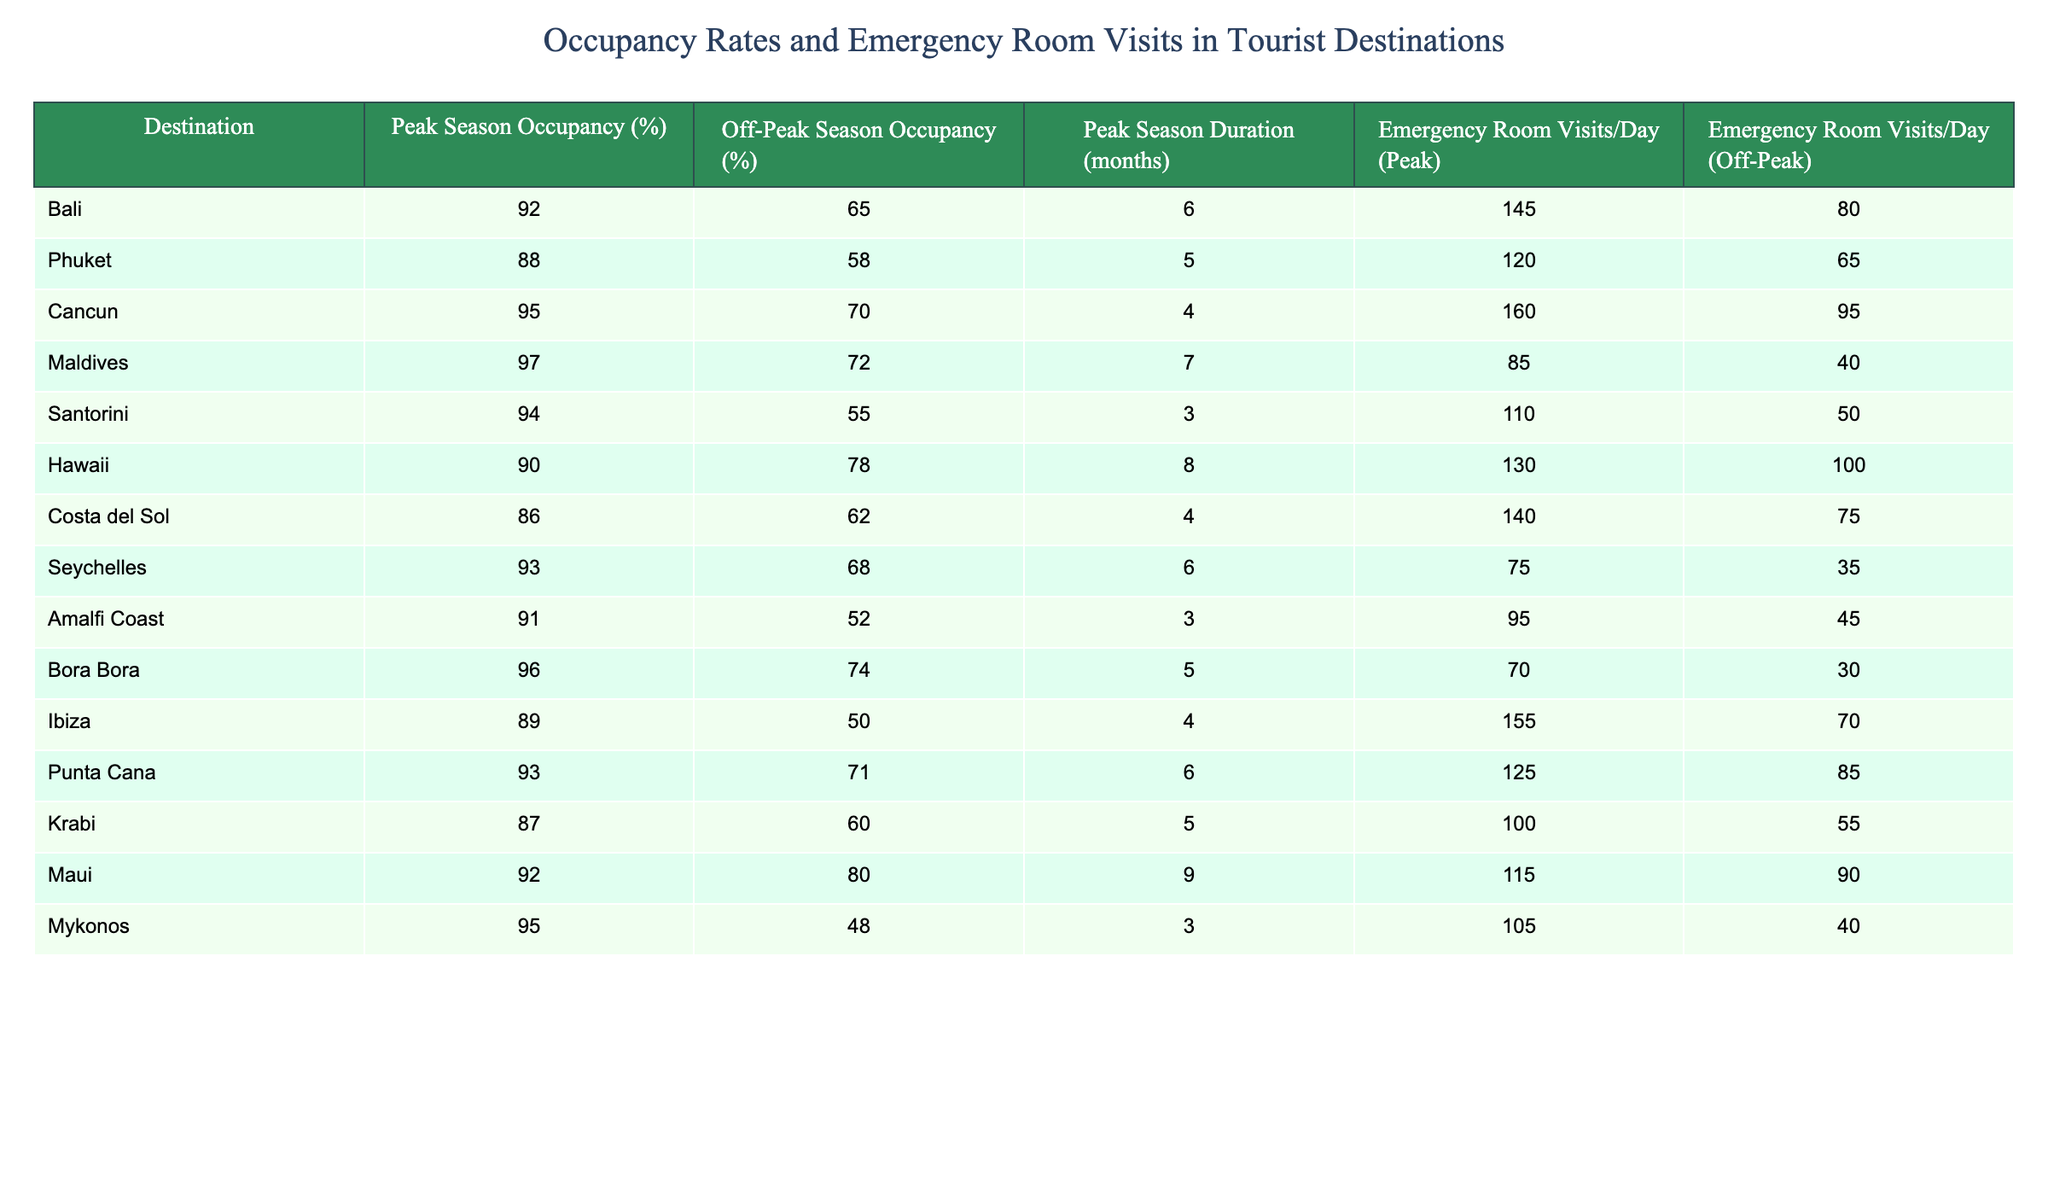What's the peak season occupancy rate for Bali? The table shows a specific occupancy rate for Bali during the peak season, which is clearly mentioned. The value is 92%.
Answer: 92% Which destination has the lowest off-peak season occupancy rate? By examining the off-peak season occupancy rates listed, we find that Santorini has the lowest rate at 55%.
Answer: Santorini What's the average peak season occupancy across all destinations? To find the average, we need to sum all the peak season occupancy rates: (92 + 88 + 95 + 97 + 94 + 90 + 86 + 93 + 91 + 96 + 89 + 93 + 87 + 92 + 95) = 1390. This sum is then divided by the number of destinations, which is 15, resulting in an average of 1390/15 = 92.67.
Answer: 92.67 How many months is the peak season in the Maldives? The table specifies the duration of the peak season for each destination; for the Maldives, it is listed as 7 months.
Answer: 7 months True or False: Emergency room visits per day in Cancun during the peak season are higher than those in Bali. According to the table, Cancun sees 160 visits per day in the peak season, while Bali has 145 visits. Since 160 is greater than 145, the statement is true.
Answer: True What is the difference in emergency room visits per day during peak and off-peak seasons for Phuket? The peak season visits for Phuket are 120, while off-peak visits are 65. The difference is calculated by subtracting off-peak from peak: 120 - 65 = 55.
Answer: 55 Which destination has more emergency room visits per day in the off-peak season, Bali or Maui? Looking at the table, Bali has 80 visits per day in the off-peak season, while Maui has 90. Since 90 is greater than 80, Maui has more visits.
Answer: Maui What is the total emergency room visits per day in peak season for all destinations combined? To find the total, sum the emergency room visits during peak season: (145 + 120 + 160 + 85 + 110 + 130 + 140 + 75 + 95 + 70 + 155 + 125 + 100 + 115 + 105) = 1860.
Answer: 1860 Which two destinations have the highest peak season occupancy rates, and what are those rates? By examining the peak season occupancy rates, the highest are for the Maldives at 97% and Cancun at 95%.
Answer: Maldives (97%), Cancun (95%) How does the average off-peak season occupancy compare to the average peak season occupancy? First, calculate the average off-peak rates: (65 + 58 + 70 + 72 + 55 + 78 + 62 + 68 + 52 + 74 + 50 + 71 + 60 + 80 + 48) = 988. The average is 988/15 = 65.87, which is compared to the average peak of 92.67.
Answer: Off-peak average (65.87%) is lower than peak average (92.67%) 